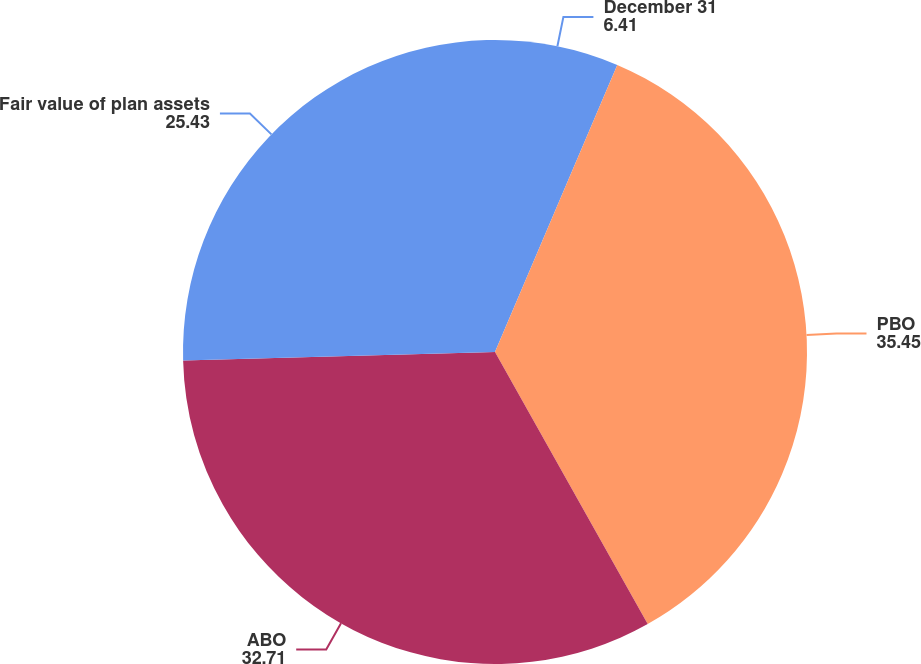<chart> <loc_0><loc_0><loc_500><loc_500><pie_chart><fcel>December 31<fcel>PBO<fcel>ABO<fcel>Fair value of plan assets<nl><fcel>6.41%<fcel>35.45%<fcel>32.71%<fcel>25.43%<nl></chart> 